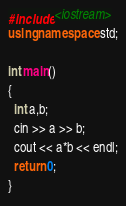Convert code to text. <code><loc_0><loc_0><loc_500><loc_500><_C++_>#include <iostream>
using namespace std;

int main()
{
  int a,b;
  cin >> a >> b;
  cout << a*b << endl;
  return 0;
}</code> 